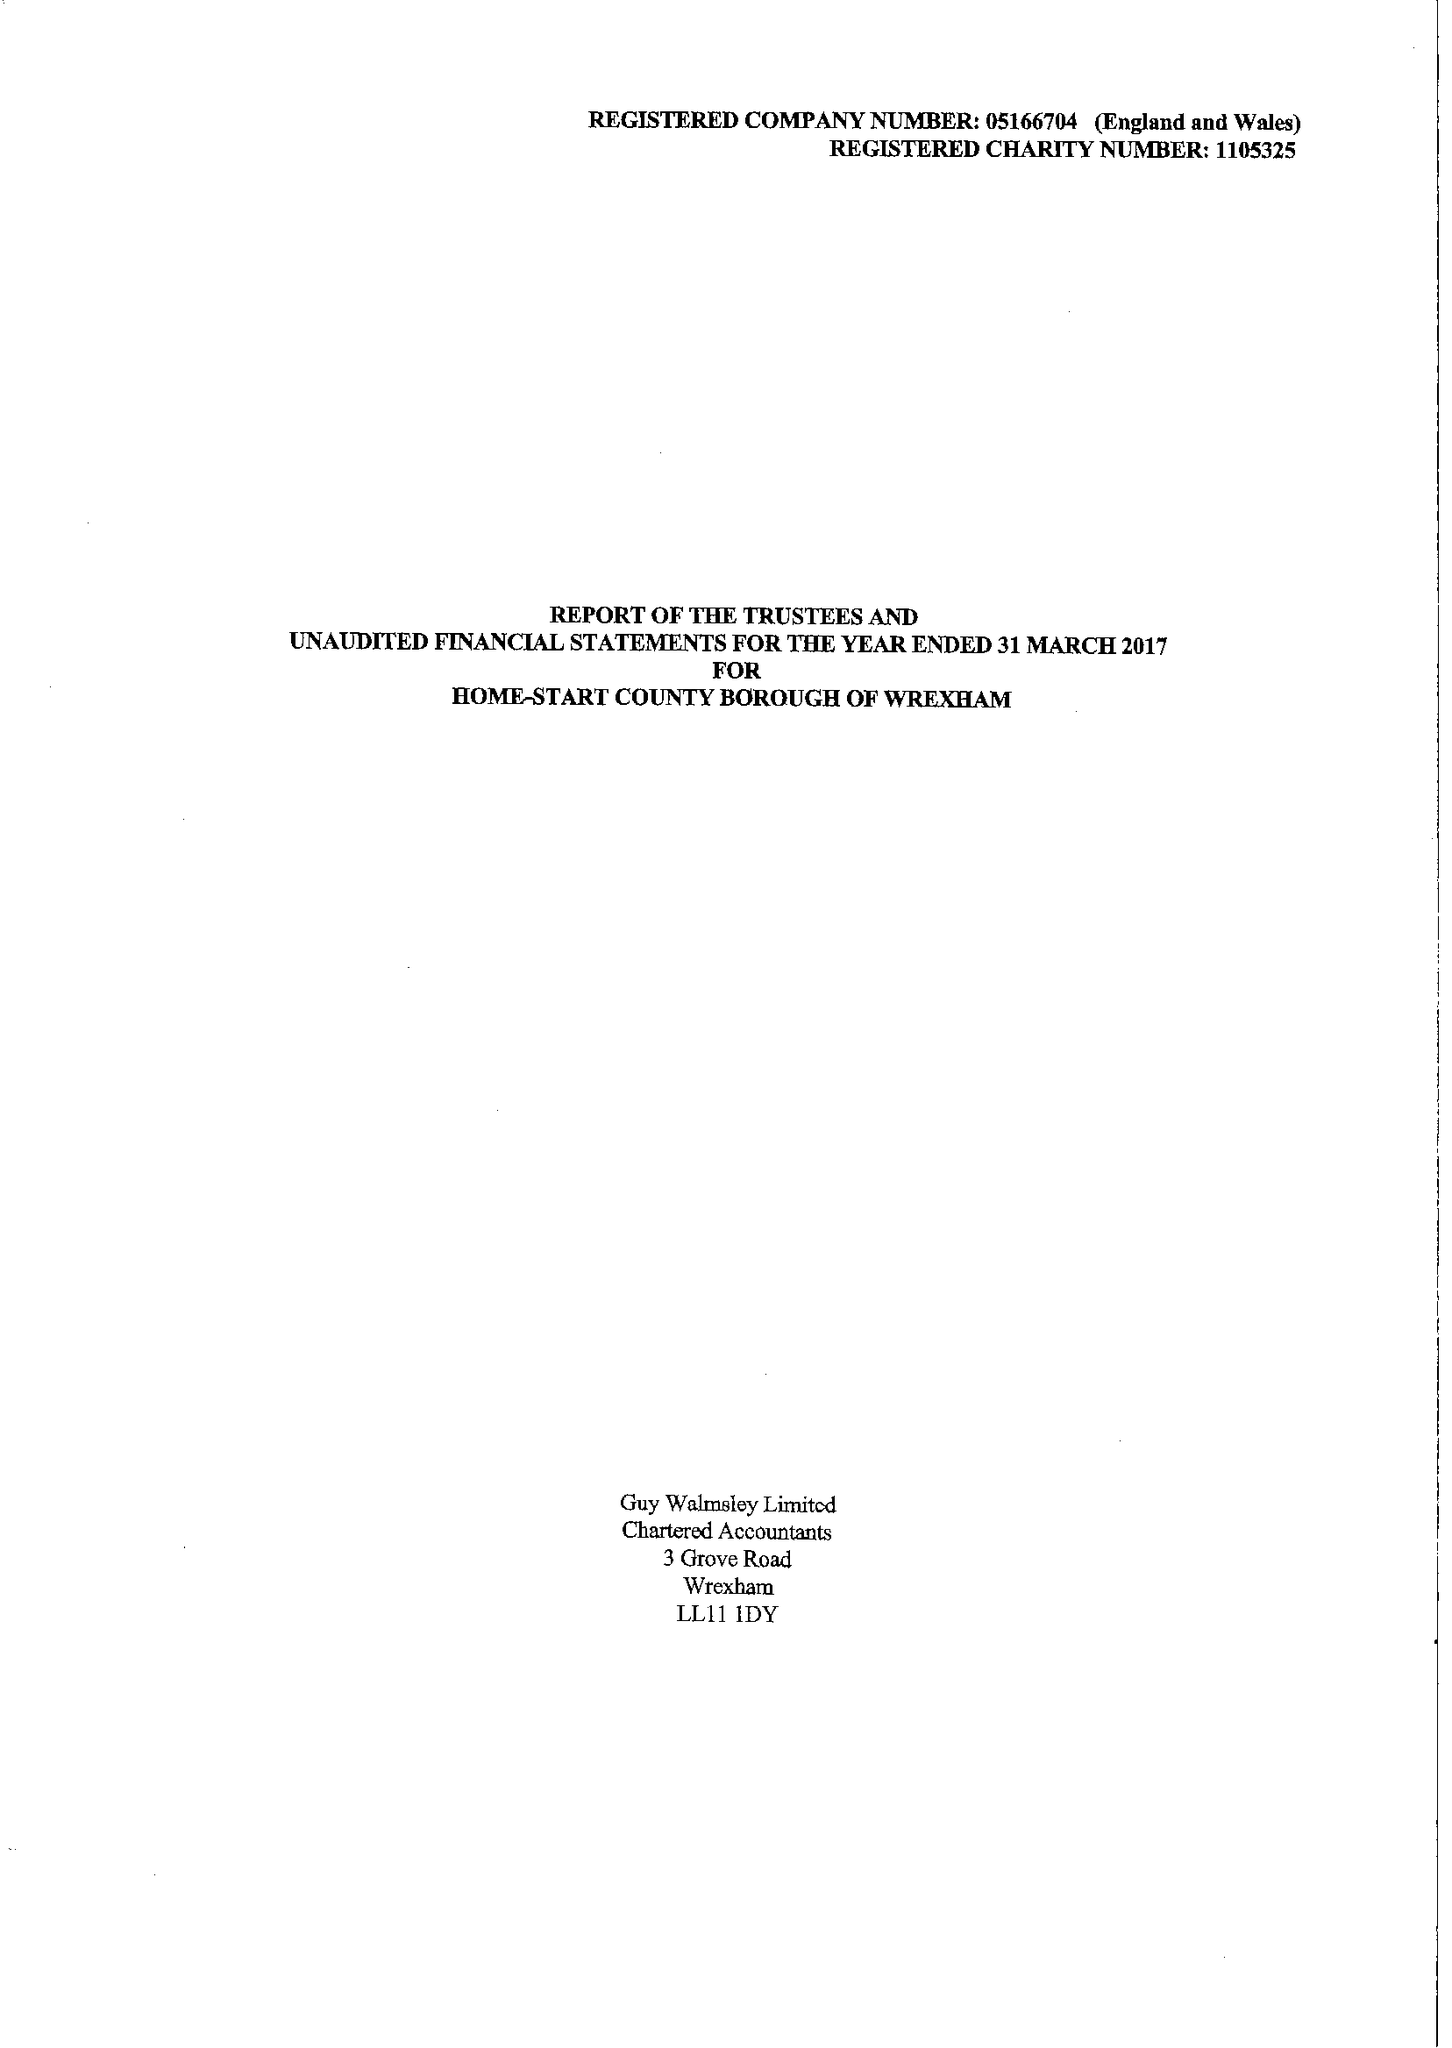What is the value for the report_date?
Answer the question using a single word or phrase. 2017-03-31 